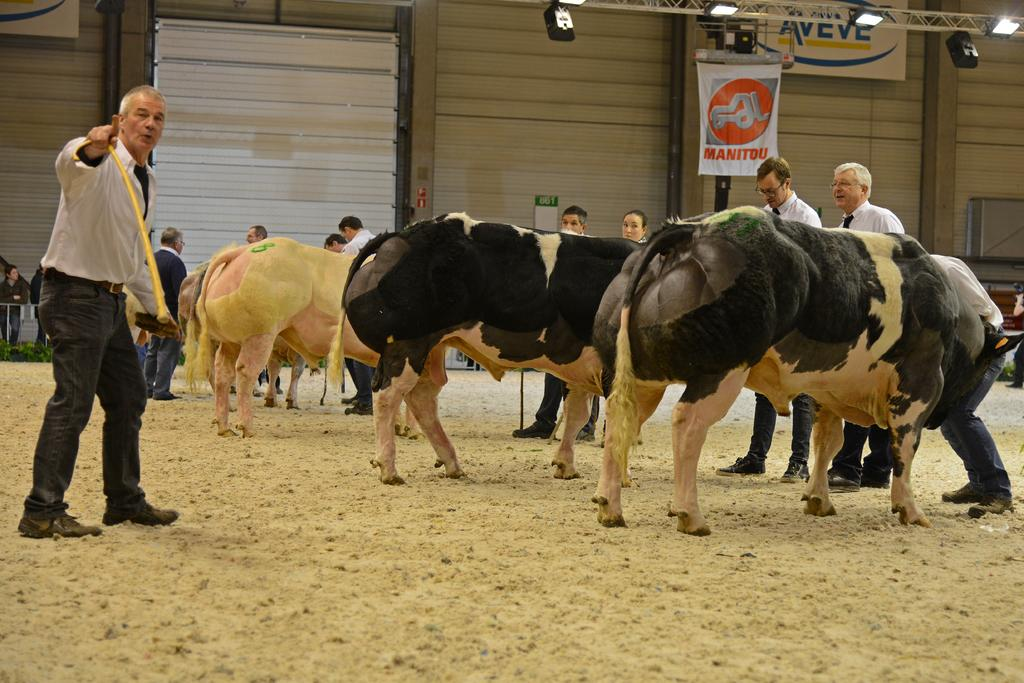How many groups of people and animals are present in the image? There is a group of people and animals in the image. What is the location of the people and animals in the image? The people and animals are on the ground in the image. What can be seen in the background of the image? In the background of the image, there is a banner, boards, a wall, lights, and some objects. What type of clocks are being operated by the animals in the image? There are no clocks present in the image, and the animals are not operating any devices. What attempt is being made by the people in the image? The image does not depict any specific attempts or actions being made by the people; they are simply standing or interacting with the animals. 